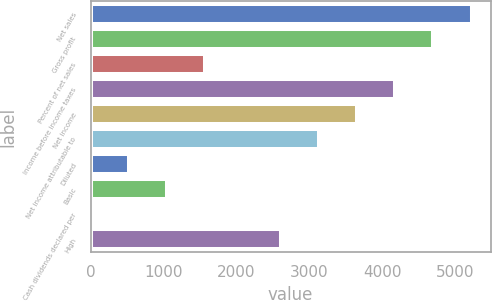Convert chart. <chart><loc_0><loc_0><loc_500><loc_500><bar_chart><fcel>Net sales<fcel>Gross profit<fcel>Percent of net sales<fcel>Income before income taxes<fcel>Net income<fcel>Net income attributable to<fcel>Diluted<fcel>Basic<fcel>Cash dividends declared per<fcel>High<nl><fcel>5223.02<fcel>4700.77<fcel>1567.28<fcel>4178.53<fcel>3656.28<fcel>3134.03<fcel>522.79<fcel>1045.03<fcel>0.55<fcel>2611.78<nl></chart> 